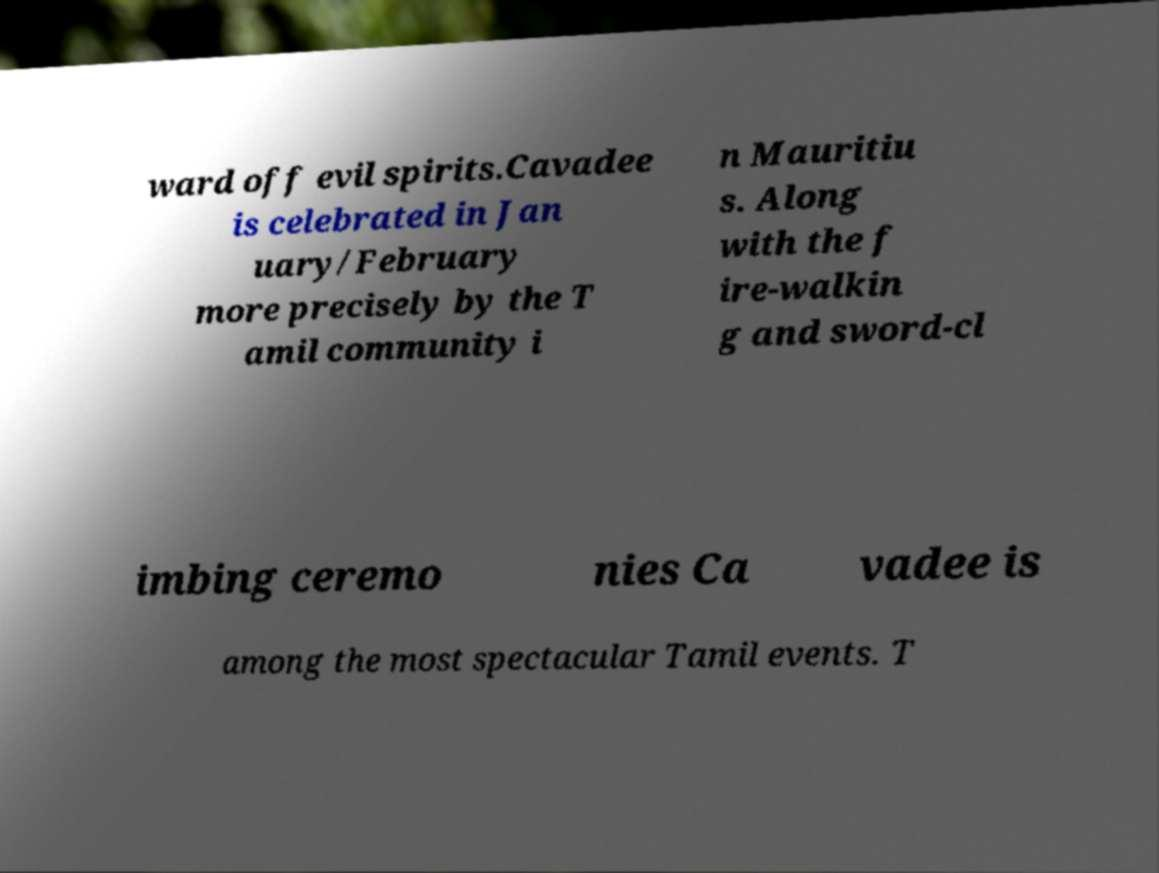Please read and relay the text visible in this image. What does it say? ward off evil spirits.Cavadee is celebrated in Jan uary/February more precisely by the T amil community i n Mauritiu s. Along with the f ire-walkin g and sword-cl imbing ceremo nies Ca vadee is among the most spectacular Tamil events. T 